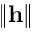<formula> <loc_0><loc_0><loc_500><loc_500>\| \mathbf h \|</formula> 